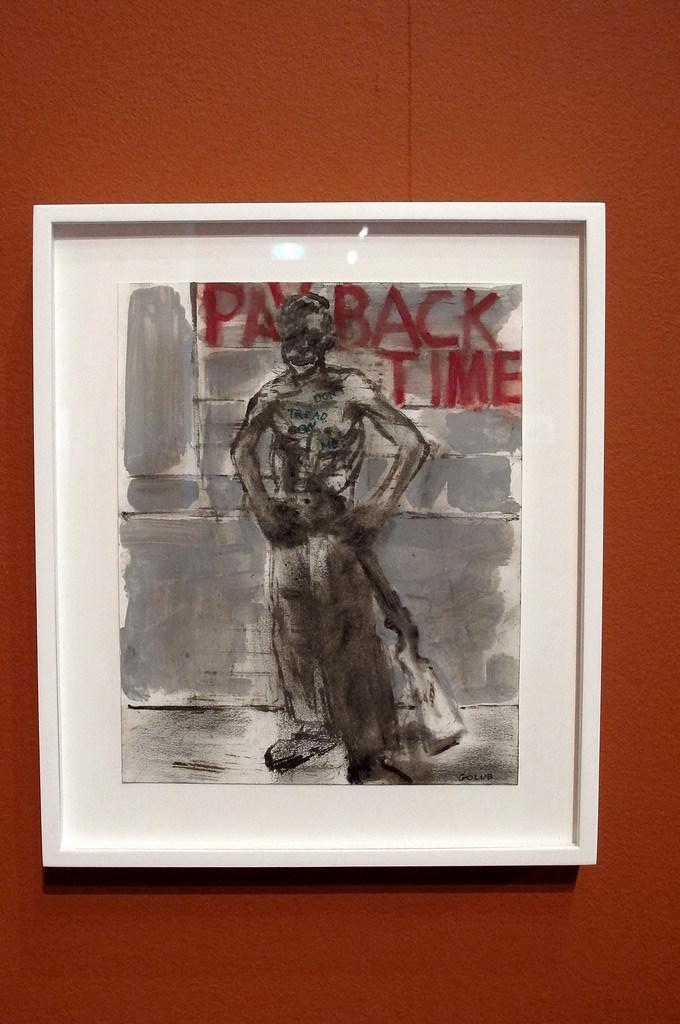<image>
Present a compact description of the photo's key features. a photo with an image of a character that says payback time 